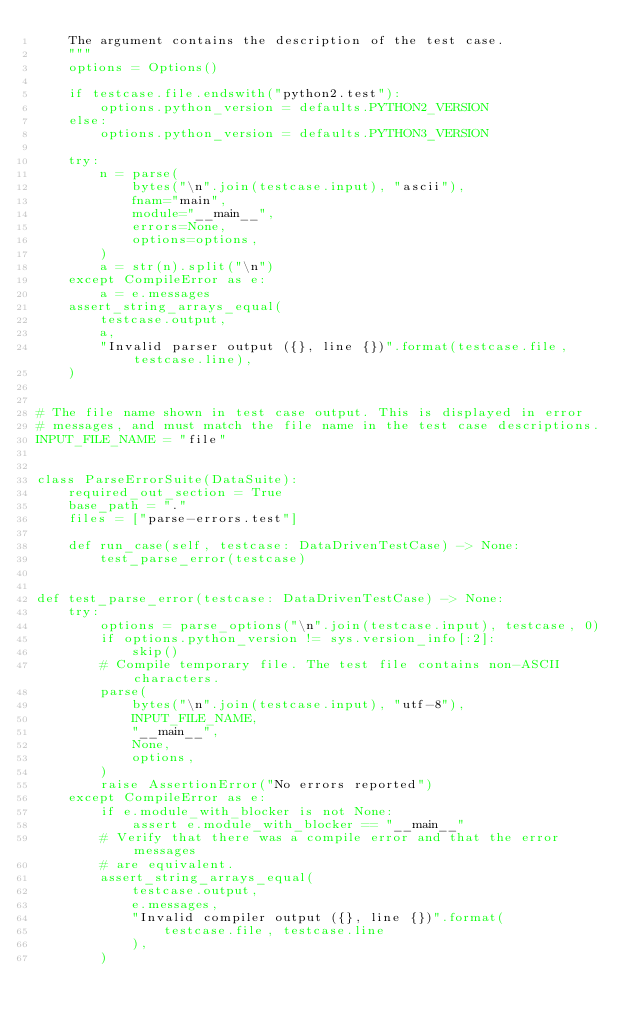Convert code to text. <code><loc_0><loc_0><loc_500><loc_500><_Python_>    The argument contains the description of the test case.
    """
    options = Options()

    if testcase.file.endswith("python2.test"):
        options.python_version = defaults.PYTHON2_VERSION
    else:
        options.python_version = defaults.PYTHON3_VERSION

    try:
        n = parse(
            bytes("\n".join(testcase.input), "ascii"),
            fnam="main",
            module="__main__",
            errors=None,
            options=options,
        )
        a = str(n).split("\n")
    except CompileError as e:
        a = e.messages
    assert_string_arrays_equal(
        testcase.output,
        a,
        "Invalid parser output ({}, line {})".format(testcase.file, testcase.line),
    )


# The file name shown in test case output. This is displayed in error
# messages, and must match the file name in the test case descriptions.
INPUT_FILE_NAME = "file"


class ParseErrorSuite(DataSuite):
    required_out_section = True
    base_path = "."
    files = ["parse-errors.test"]

    def run_case(self, testcase: DataDrivenTestCase) -> None:
        test_parse_error(testcase)


def test_parse_error(testcase: DataDrivenTestCase) -> None:
    try:
        options = parse_options("\n".join(testcase.input), testcase, 0)
        if options.python_version != sys.version_info[:2]:
            skip()
        # Compile temporary file. The test file contains non-ASCII characters.
        parse(
            bytes("\n".join(testcase.input), "utf-8"),
            INPUT_FILE_NAME,
            "__main__",
            None,
            options,
        )
        raise AssertionError("No errors reported")
    except CompileError as e:
        if e.module_with_blocker is not None:
            assert e.module_with_blocker == "__main__"
        # Verify that there was a compile error and that the error messages
        # are equivalent.
        assert_string_arrays_equal(
            testcase.output,
            e.messages,
            "Invalid compiler output ({}, line {})".format(
                testcase.file, testcase.line
            ),
        )
</code> 